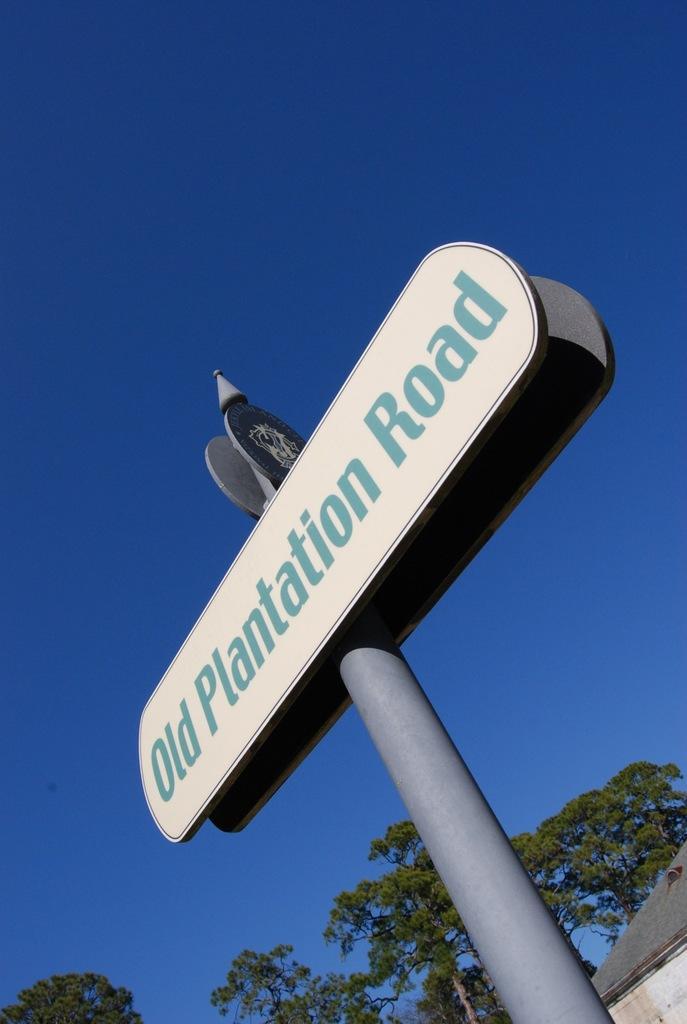Please provide a concise description of this image. Here I can see a pole to which two boards are attached. On the board, I can see some text. At the bottom there are some trees and a house. In the background, I can see the sky. 